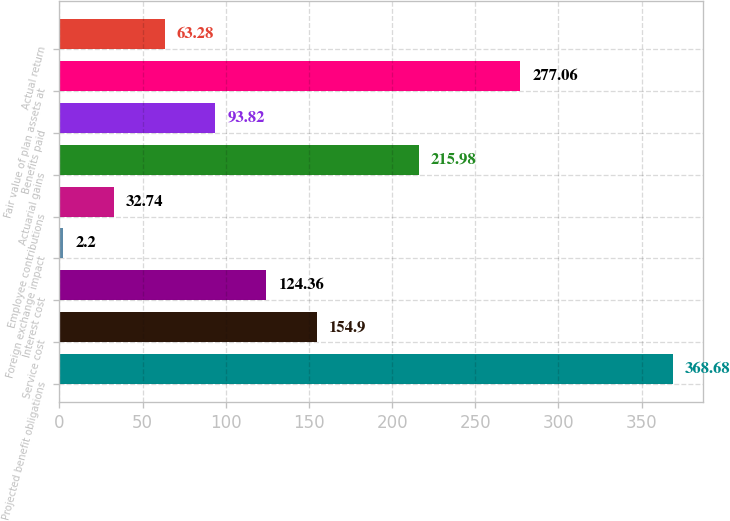Convert chart to OTSL. <chart><loc_0><loc_0><loc_500><loc_500><bar_chart><fcel>Projected benefit obligations<fcel>Service cost<fcel>Interest cost<fcel>Foreign exchange impact<fcel>Employee contributions<fcel>Actuarial gains<fcel>Benefits paid<fcel>Fair value of plan assets at<fcel>Actual return<nl><fcel>368.68<fcel>154.9<fcel>124.36<fcel>2.2<fcel>32.74<fcel>215.98<fcel>93.82<fcel>277.06<fcel>63.28<nl></chart> 